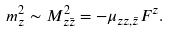Convert formula to latex. <formula><loc_0><loc_0><loc_500><loc_500>m _ { z } ^ { 2 } \sim M _ { z \bar { z } } ^ { 2 } = - \mu _ { z z , \bar { z } } F ^ { z } .</formula> 